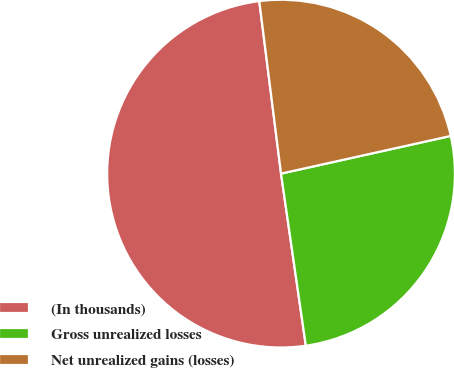Convert chart. <chart><loc_0><loc_0><loc_500><loc_500><pie_chart><fcel>(In thousands)<fcel>Gross unrealized losses<fcel>Net unrealized gains (losses)<nl><fcel>50.28%<fcel>26.2%<fcel>23.52%<nl></chart> 